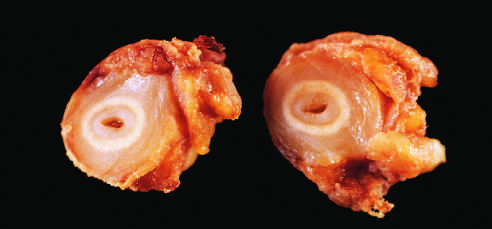s the b-cell antigen receptor complex the area of intimal hyperplasia?
Answer the question using a single word or phrase. No 